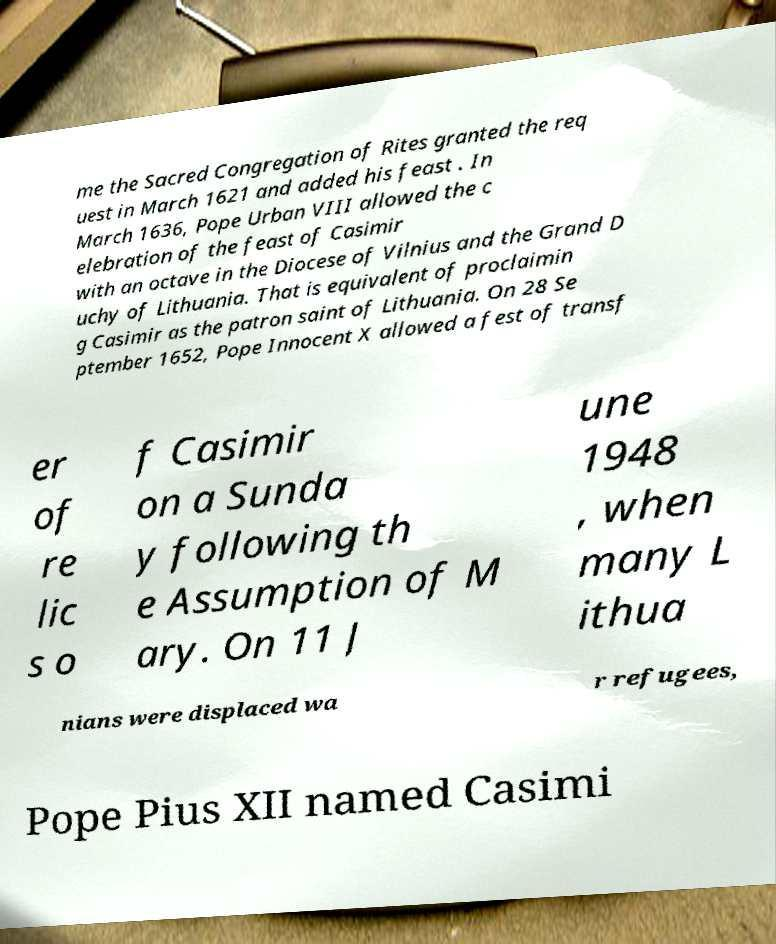Please read and relay the text visible in this image. What does it say? me the Sacred Congregation of Rites granted the req uest in March 1621 and added his feast . In March 1636, Pope Urban VIII allowed the c elebration of the feast of Casimir with an octave in the Diocese of Vilnius and the Grand D uchy of Lithuania. That is equivalent of proclaimin g Casimir as the patron saint of Lithuania. On 28 Se ptember 1652, Pope Innocent X allowed a fest of transf er of re lic s o f Casimir on a Sunda y following th e Assumption of M ary. On 11 J une 1948 , when many L ithua nians were displaced wa r refugees, Pope Pius XII named Casimi 